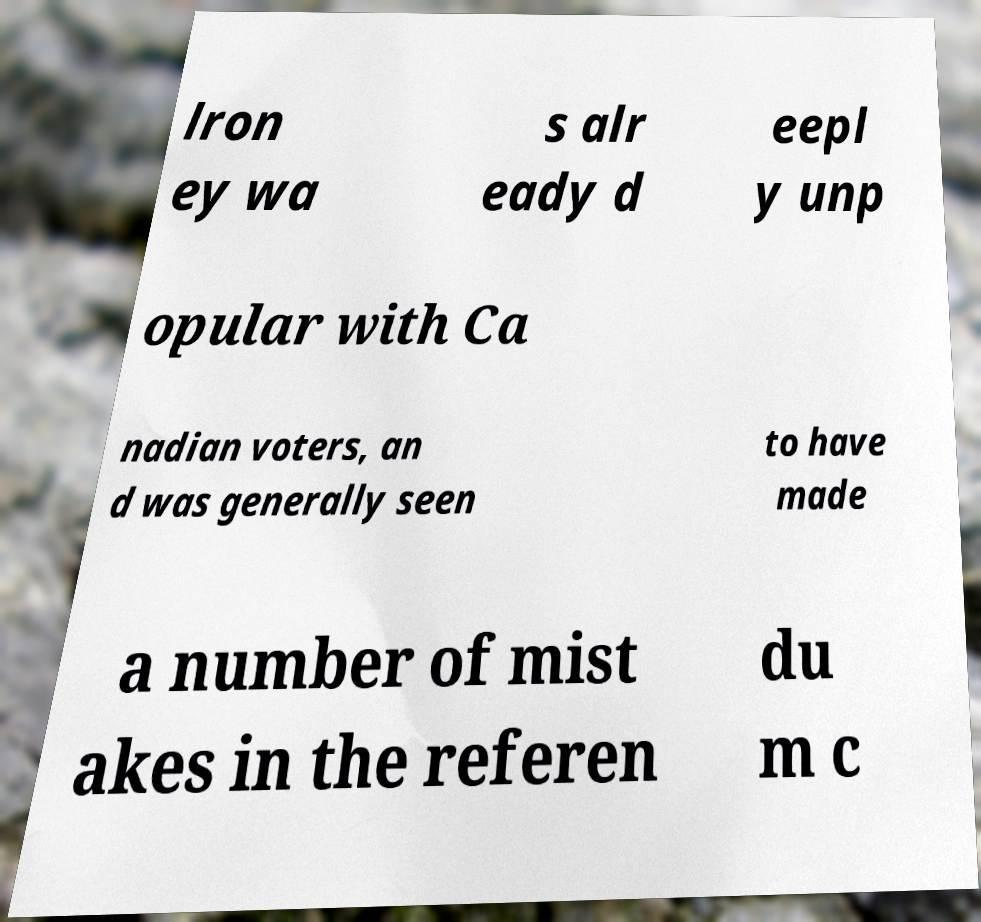Please identify and transcribe the text found in this image. lron ey wa s alr eady d eepl y unp opular with Ca nadian voters, an d was generally seen to have made a number of mist akes in the referen du m c 